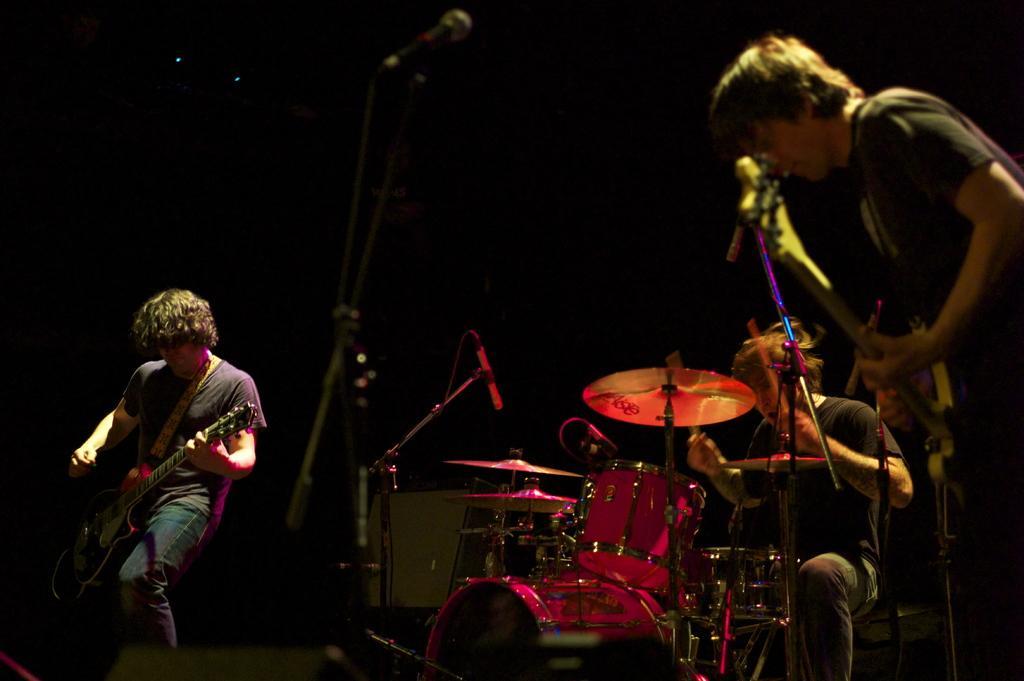Describe this image in one or two sentences. On the right side of the image a man is standing and holding a guitar on his hand and playing, beside him a man is sitting and playing the drums. On the left side of the image a man is carrying a guitar. In the middle of the image a mic and band are present. 